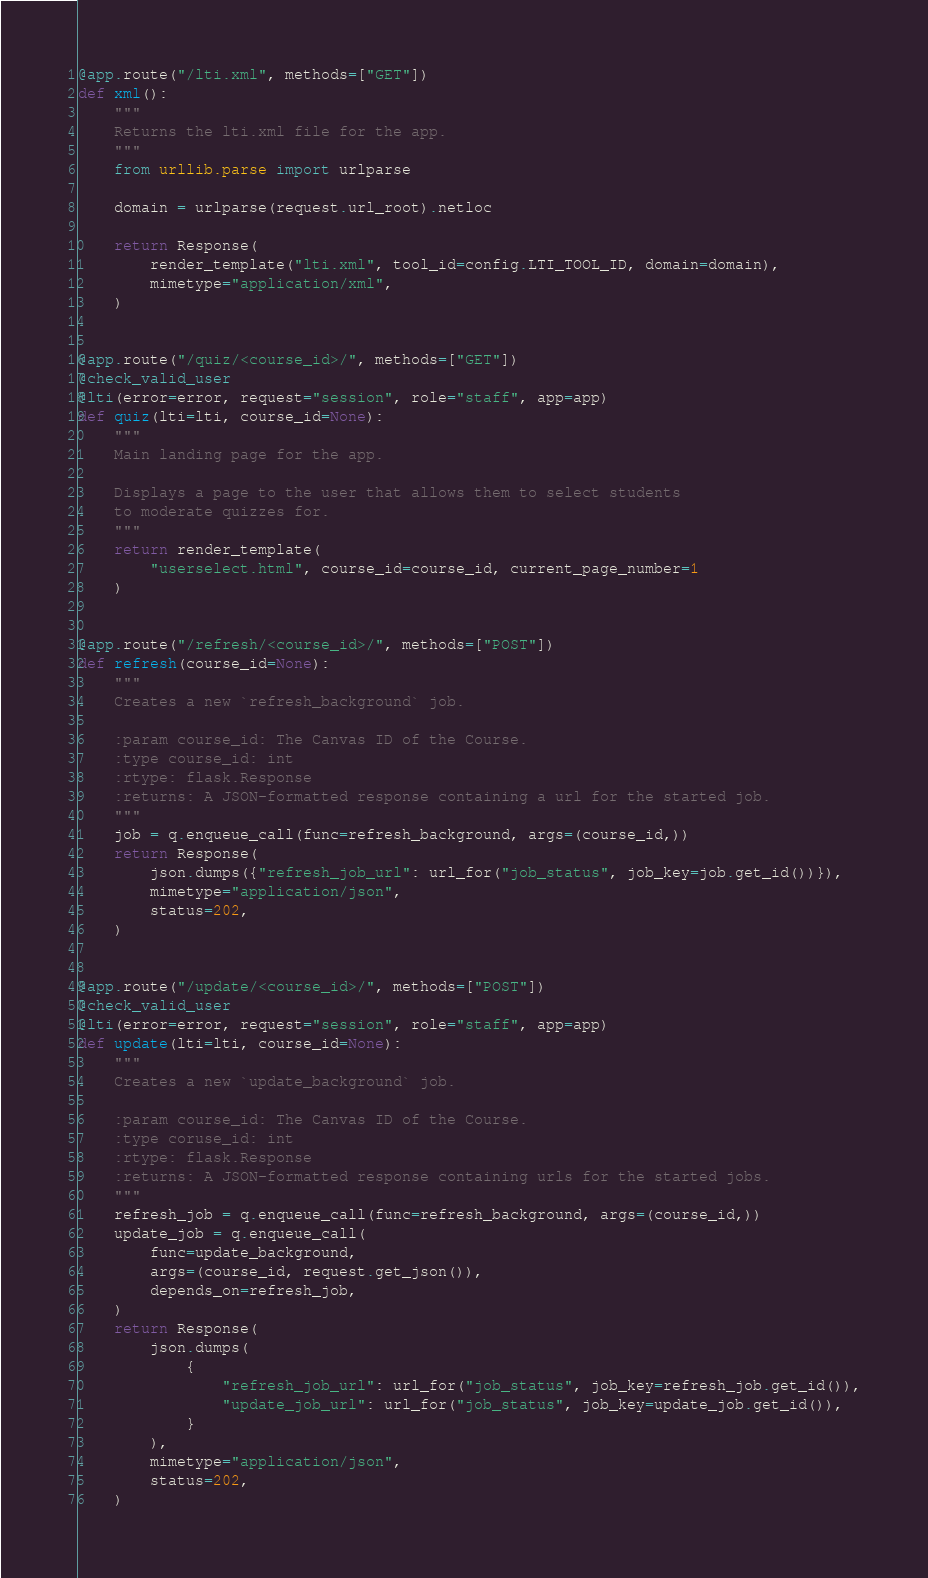<code> <loc_0><loc_0><loc_500><loc_500><_Python_>

@app.route("/lti.xml", methods=["GET"])
def xml():
    """
    Returns the lti.xml file for the app.
    """
    from urllib.parse import urlparse

    domain = urlparse(request.url_root).netloc

    return Response(
        render_template("lti.xml", tool_id=config.LTI_TOOL_ID, domain=domain),
        mimetype="application/xml",
    )


@app.route("/quiz/<course_id>/", methods=["GET"])
@check_valid_user
@lti(error=error, request="session", role="staff", app=app)
def quiz(lti=lti, course_id=None):
    """
    Main landing page for the app.

    Displays a page to the user that allows them to select students
    to moderate quizzes for.
    """
    return render_template(
        "userselect.html", course_id=course_id, current_page_number=1
    )


@app.route("/refresh/<course_id>/", methods=["POST"])
def refresh(course_id=None):
    """
    Creates a new `refresh_background` job.

    :param course_id: The Canvas ID of the Course.
    :type course_id: int
    :rtype: flask.Response
    :returns: A JSON-formatted response containing a url for the started job.
    """
    job = q.enqueue_call(func=refresh_background, args=(course_id,))
    return Response(
        json.dumps({"refresh_job_url": url_for("job_status", job_key=job.get_id())}),
        mimetype="application/json",
        status=202,
    )


@app.route("/update/<course_id>/", methods=["POST"])
@check_valid_user
@lti(error=error, request="session", role="staff", app=app)
def update(lti=lti, course_id=None):
    """
    Creates a new `update_background` job.

    :param course_id: The Canvas ID of the Course.
    :type coruse_id: int
    :rtype: flask.Response
    :returns: A JSON-formatted response containing urls for the started jobs.
    """
    refresh_job = q.enqueue_call(func=refresh_background, args=(course_id,))
    update_job = q.enqueue_call(
        func=update_background,
        args=(course_id, request.get_json()),
        depends_on=refresh_job,
    )
    return Response(
        json.dumps(
            {
                "refresh_job_url": url_for("job_status", job_key=refresh_job.get_id()),
                "update_job_url": url_for("job_status", job_key=update_job.get_id()),
            }
        ),
        mimetype="application/json",
        status=202,
    )

</code> 